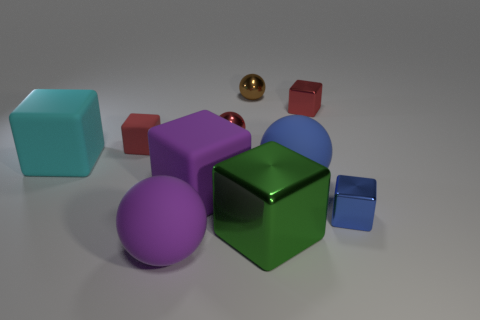The cyan object has what shape?
Your answer should be very brief. Cube. Are there more blue metallic things that are behind the brown ball than red rubber cubes in front of the large green shiny object?
Ensure brevity in your answer.  No. Does the matte object that is right of the red sphere have the same color as the small metal object that is in front of the cyan matte block?
Provide a short and direct response. Yes. What is the shape of the cyan matte object that is the same size as the green block?
Provide a short and direct response. Cube. Are there any other tiny objects of the same shape as the tiny blue thing?
Provide a short and direct response. Yes. Is the large sphere in front of the small blue shiny block made of the same material as the small red cube that is to the right of the small brown shiny sphere?
Your answer should be very brief. No. What number of small blue things have the same material as the large cyan thing?
Your answer should be compact. 0. The tiny matte cube has what color?
Your response must be concise. Red. Does the red metal thing that is on the left side of the brown metallic thing have the same shape as the large purple thing that is behind the small blue shiny cube?
Your answer should be compact. No. The large rubber ball behind the large purple rubber block is what color?
Ensure brevity in your answer.  Blue. 